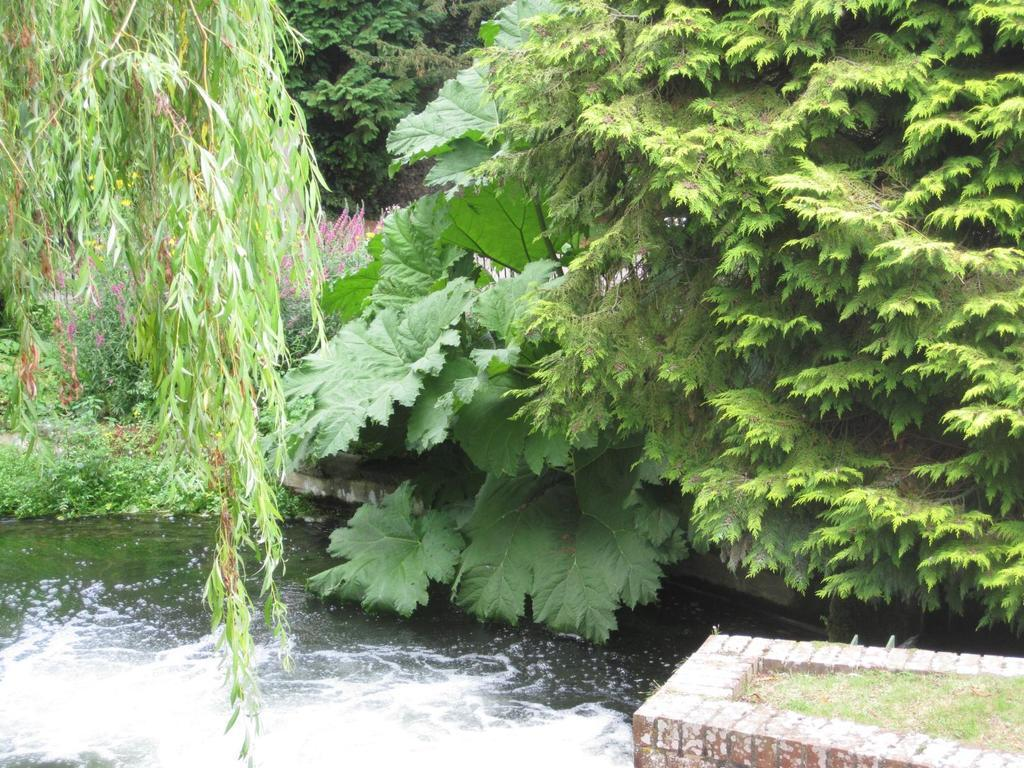What is located in the center of the image? There are trees, plants, and grass in the center of the image. What type of natural elements can be seen in the image? Trees, plants, grass, and water are visible in the image. What type of structure is present in the image? There is a brick wall in the image. What grade is the fire burning in the image? There is no fire present in the image, so it is not possible to determine the grade of a fire. 